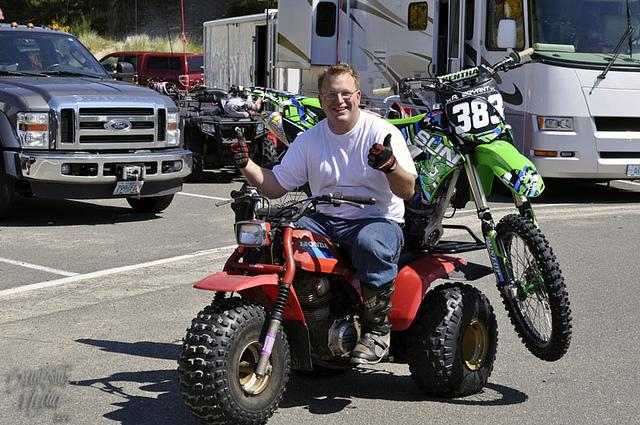Why does he have a bike on the back of his vehicle?

Choices:
A) transporting it
B) stealing it
C) found it
D) selling it transporting it 